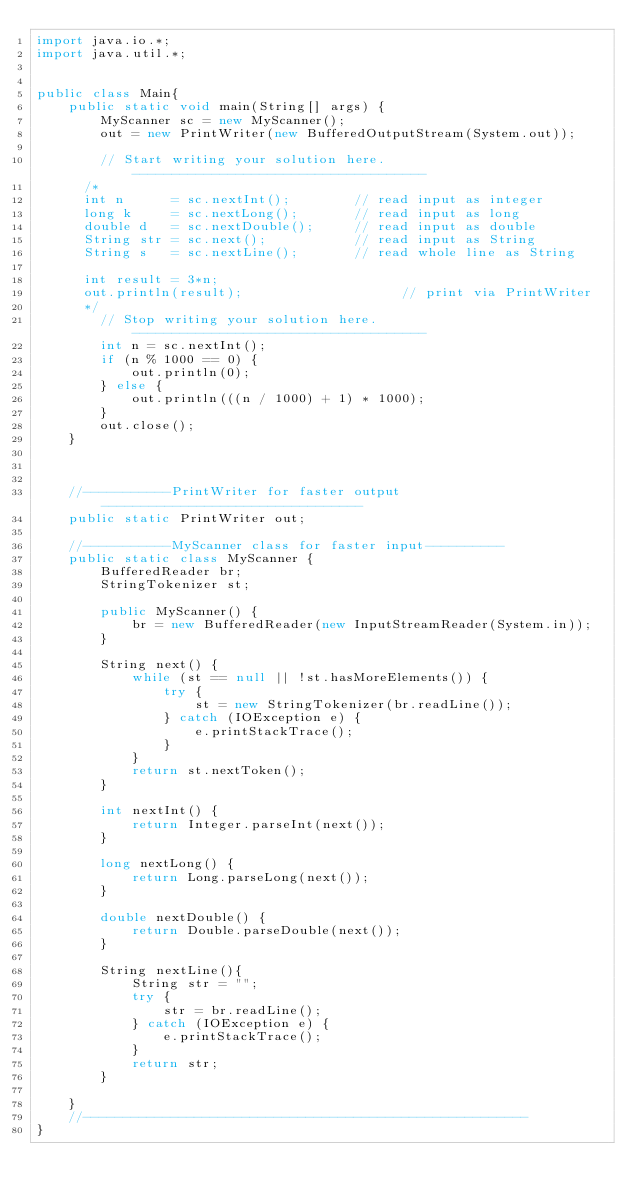Convert code to text. <code><loc_0><loc_0><loc_500><loc_500><_Java_>import java.io.*;
import java.util.*;


public class Main{
    public static void main(String[] args) {
        MyScanner sc = new MyScanner();
        out = new PrintWriter(new BufferedOutputStream(System.out));

        // Start writing your solution here. -------------------------------------
      /*
      int n      = sc.nextInt();        // read input as integer
      long k     = sc.nextLong();       // read input as long
      double d   = sc.nextDouble();     // read input as double
      String str = sc.next();           // read input as String
      String s   = sc.nextLine();       // read whole line as String

      int result = 3*n;
      out.println(result);                    // print via PrintWriter
      */
        // Stop writing your solution here. -------------------------------------
        int n = sc.nextInt();
        if (n % 1000 == 0) {
            out.println(0);
        } else {
            out.println(((n / 1000) + 1) * 1000);
        }
        out.close();
    }



    //-----------PrintWriter for faster output---------------------------------
    public static PrintWriter out;

    //-----------MyScanner class for faster input----------
    public static class MyScanner {
        BufferedReader br;
        StringTokenizer st;

        public MyScanner() {
            br = new BufferedReader(new InputStreamReader(System.in));
        }

        String next() {
            while (st == null || !st.hasMoreElements()) {
                try {
                    st = new StringTokenizer(br.readLine());
                } catch (IOException e) {
                    e.printStackTrace();
                }
            }
            return st.nextToken();
        }

        int nextInt() {
            return Integer.parseInt(next());
        }

        long nextLong() {
            return Long.parseLong(next());
        }

        double nextDouble() {
            return Double.parseDouble(next());
        }

        String nextLine(){
            String str = "";
            try {
                str = br.readLine();
            } catch (IOException e) {
                e.printStackTrace();
            }
            return str;
        }

    }
    //--------------------------------------------------------
}</code> 